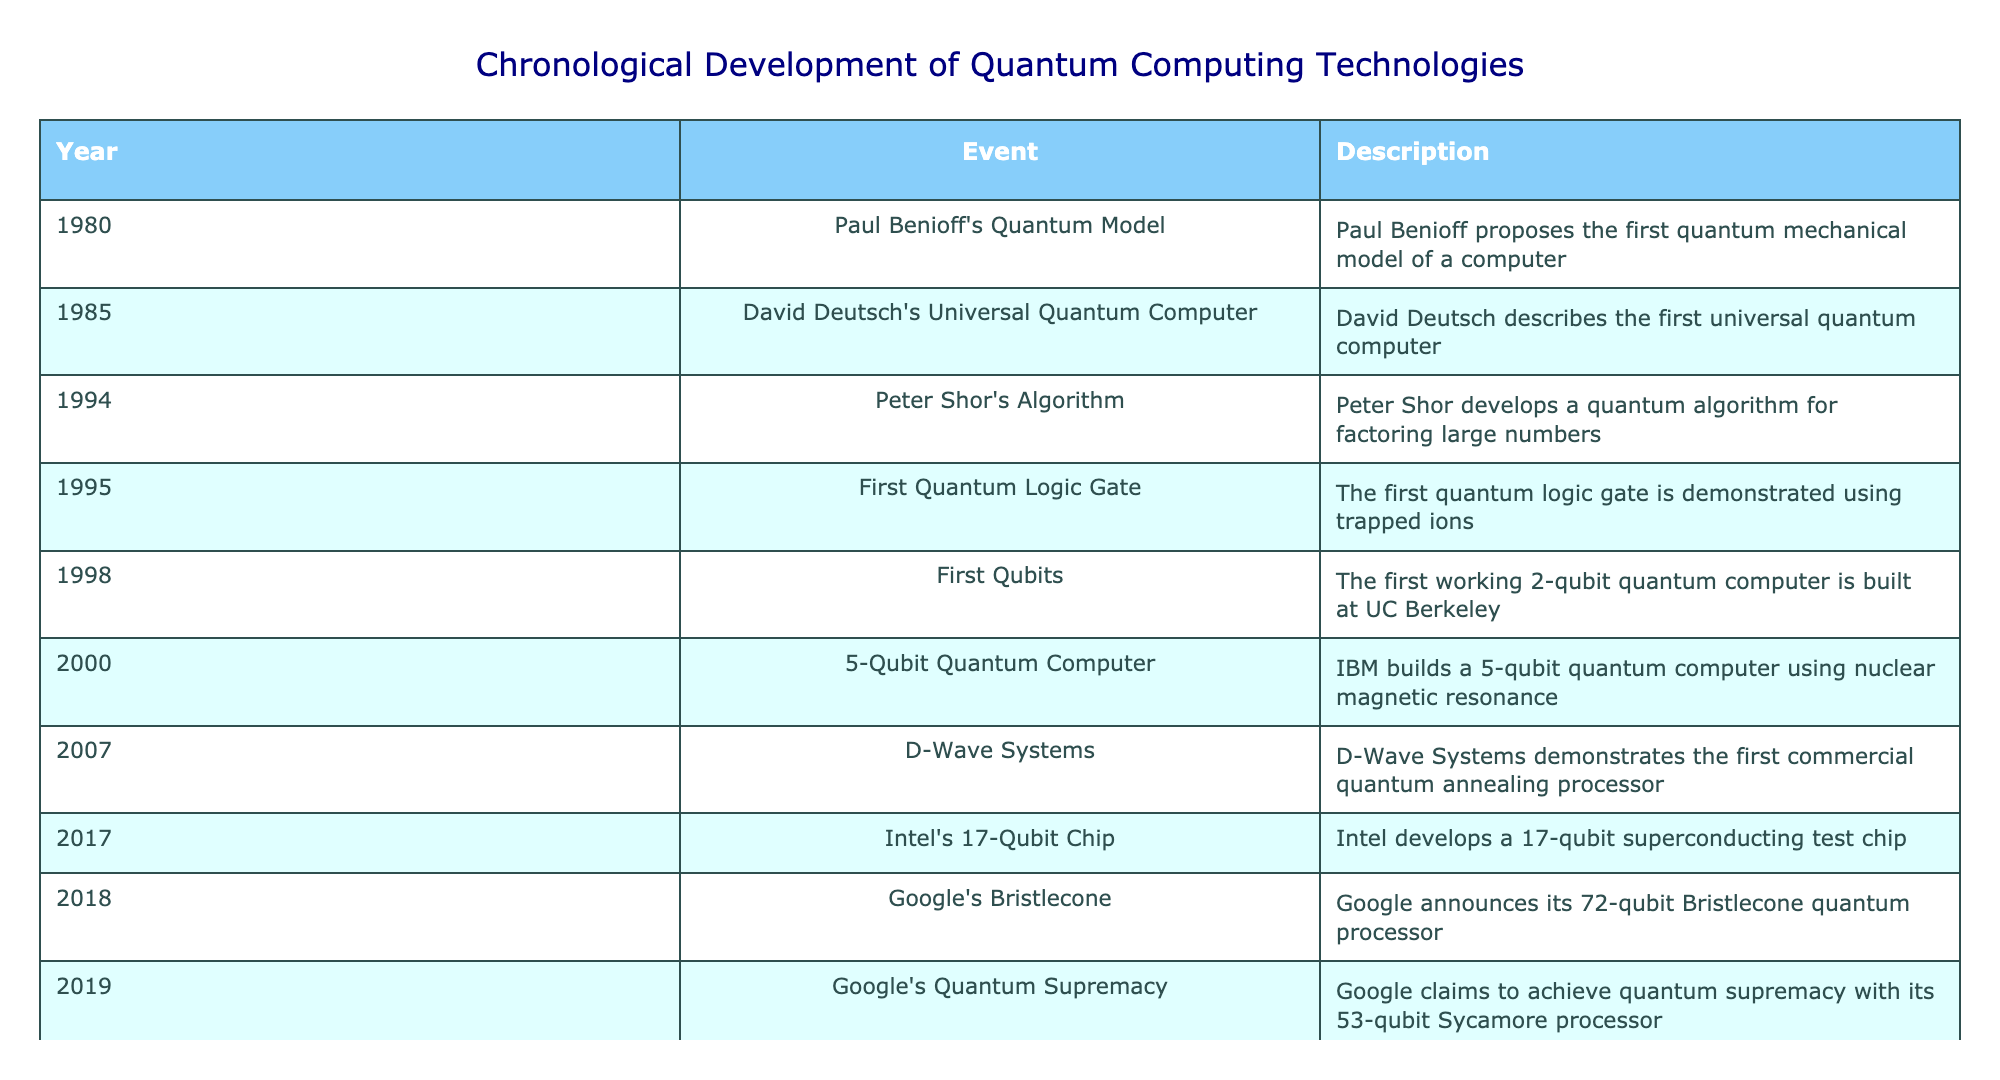What year did Peter Shor develop his quantum algorithm? According to the table, Peter Shor's algorithm was developed in 1994.
Answer: 1994 What is the event associated with the year 2007? The table shows that in 2007, the event was the demonstration of D-Wave Systems' first commercial quantum annealing processor.
Answer: D-Wave Systems How many years elapsed between the announcement of Google's Bristlecone and the claim of quantum supremacy? The event of Google's Bristlecone occurred in 2018 and quantum supremacy was claimed in 2019. The difference is 2019 - 2018 = 1 year.
Answer: 1 year Did IBM build a quantum computer before the first qubits were developed at UC Berkeley? From the table, IBM built a 5-qubit quantum computer in 2000, while the first working 2-qubit quantum computer was built in 1998 at UC Berkeley. Since 2000 is after 1998, the statement is false.
Answer: No What is the total number of qubits mentioned in the events occurring in 2017 and 2018? In 2017, Intel's chip had 17 qubits and in 2018, Google announced a 72-qubit processor. Adding these, 17 + 72 = 89 qubits.
Answer: 89 qubits What was the first event listed in the chronological development of quantum computing technologies? The table presents Paul Benioff's Quantum Model as the first event in 1980.
Answer: Paul Benioff's Quantum Model Which event describes the first working quantum logic gate? The table indicates that the first quantum logic gate was demonstrated in 1995 using trapped ions.
Answer: 1995 - First Quantum Logic Gate How many events occurred before the year 2000? Referring to the table, the events before 2000 are from 1980 to 1999, which totals to 5 events: 1980, 1985, 1994, 1995, and 1998.
Answer: 5 events 